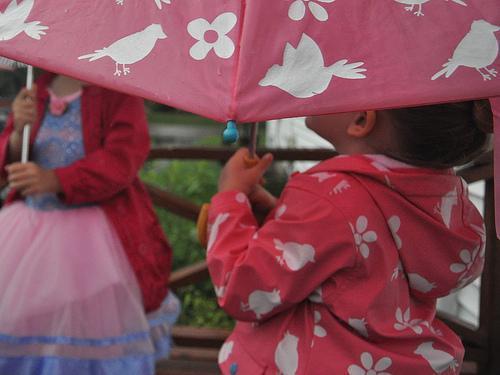How many umbrellas are there?
Give a very brief answer. 1. 